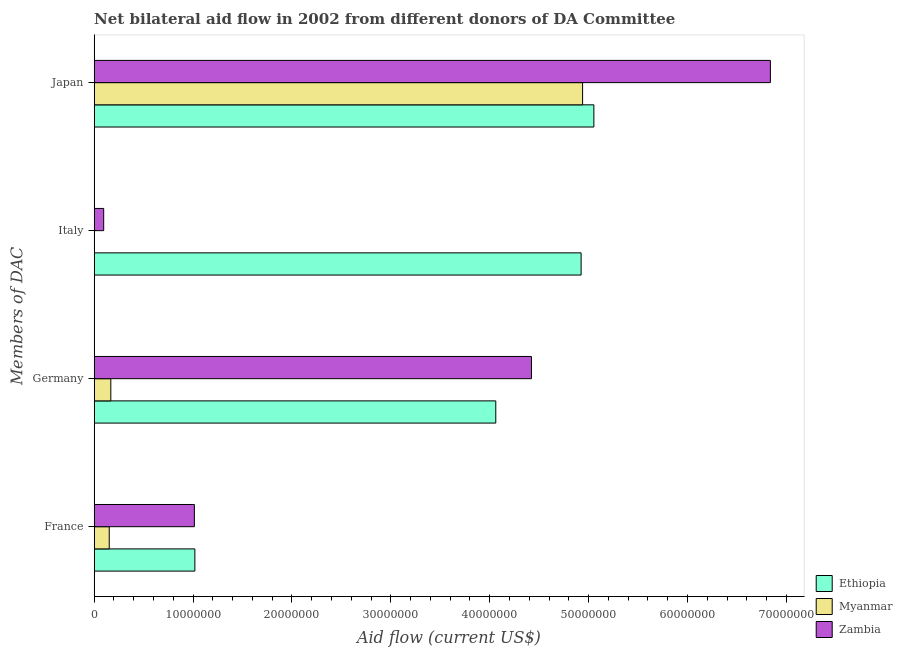How many different coloured bars are there?
Make the answer very short. 3. Are the number of bars on each tick of the Y-axis equal?
Make the answer very short. Yes. How many bars are there on the 4th tick from the bottom?
Offer a very short reply. 3. What is the amount of aid given by japan in Myanmar?
Give a very brief answer. 4.94e+07. Across all countries, what is the maximum amount of aid given by germany?
Give a very brief answer. 4.42e+07. Across all countries, what is the minimum amount of aid given by italy?
Offer a terse response. 2.00e+04. In which country was the amount of aid given by italy maximum?
Give a very brief answer. Ethiopia. In which country was the amount of aid given by germany minimum?
Offer a terse response. Myanmar. What is the total amount of aid given by france in the graph?
Offer a terse response. 2.18e+07. What is the difference between the amount of aid given by japan in Zambia and that in Myanmar?
Your response must be concise. 1.90e+07. What is the difference between the amount of aid given by italy in Zambia and the amount of aid given by france in Ethiopia?
Your answer should be compact. -9.22e+06. What is the average amount of aid given by france per country?
Provide a short and direct response. 7.28e+06. What is the difference between the amount of aid given by italy and amount of aid given by japan in Myanmar?
Make the answer very short. -4.94e+07. What is the ratio of the amount of aid given by france in Myanmar to that in Ethiopia?
Make the answer very short. 0.15. Is the difference between the amount of aid given by japan in Myanmar and Ethiopia greater than the difference between the amount of aid given by italy in Myanmar and Ethiopia?
Your response must be concise. Yes. What is the difference between the highest and the second highest amount of aid given by japan?
Make the answer very short. 1.78e+07. What is the difference between the highest and the lowest amount of aid given by france?
Your answer should be very brief. 8.66e+06. What does the 1st bar from the top in Japan represents?
Make the answer very short. Zambia. What does the 3rd bar from the bottom in Italy represents?
Offer a very short reply. Zambia. How many countries are there in the graph?
Keep it short and to the point. 3. What is the difference between two consecutive major ticks on the X-axis?
Make the answer very short. 1.00e+07. Does the graph contain any zero values?
Your answer should be compact. No. Does the graph contain grids?
Give a very brief answer. No. Where does the legend appear in the graph?
Your answer should be very brief. Bottom right. How are the legend labels stacked?
Make the answer very short. Vertical. What is the title of the graph?
Your response must be concise. Net bilateral aid flow in 2002 from different donors of DA Committee. What is the label or title of the X-axis?
Give a very brief answer. Aid flow (current US$). What is the label or title of the Y-axis?
Your answer should be very brief. Members of DAC. What is the Aid flow (current US$) of Ethiopia in France?
Give a very brief answer. 1.02e+07. What is the Aid flow (current US$) of Myanmar in France?
Keep it short and to the point. 1.52e+06. What is the Aid flow (current US$) of Zambia in France?
Give a very brief answer. 1.01e+07. What is the Aid flow (current US$) in Ethiopia in Germany?
Your answer should be compact. 4.06e+07. What is the Aid flow (current US$) of Myanmar in Germany?
Your response must be concise. 1.68e+06. What is the Aid flow (current US$) of Zambia in Germany?
Provide a succinct answer. 4.42e+07. What is the Aid flow (current US$) in Ethiopia in Italy?
Provide a succinct answer. 4.92e+07. What is the Aid flow (current US$) in Myanmar in Italy?
Ensure brevity in your answer.  2.00e+04. What is the Aid flow (current US$) of Zambia in Italy?
Provide a short and direct response. 9.60e+05. What is the Aid flow (current US$) in Ethiopia in Japan?
Make the answer very short. 5.05e+07. What is the Aid flow (current US$) of Myanmar in Japan?
Your response must be concise. 4.94e+07. What is the Aid flow (current US$) in Zambia in Japan?
Give a very brief answer. 6.84e+07. Across all Members of DAC, what is the maximum Aid flow (current US$) in Ethiopia?
Your response must be concise. 5.05e+07. Across all Members of DAC, what is the maximum Aid flow (current US$) in Myanmar?
Give a very brief answer. 4.94e+07. Across all Members of DAC, what is the maximum Aid flow (current US$) in Zambia?
Keep it short and to the point. 6.84e+07. Across all Members of DAC, what is the minimum Aid flow (current US$) of Ethiopia?
Make the answer very short. 1.02e+07. Across all Members of DAC, what is the minimum Aid flow (current US$) of Myanmar?
Your answer should be compact. 2.00e+04. Across all Members of DAC, what is the minimum Aid flow (current US$) in Zambia?
Provide a succinct answer. 9.60e+05. What is the total Aid flow (current US$) of Ethiopia in the graph?
Provide a succinct answer. 1.51e+08. What is the total Aid flow (current US$) in Myanmar in the graph?
Your answer should be very brief. 5.26e+07. What is the total Aid flow (current US$) of Zambia in the graph?
Make the answer very short. 1.24e+08. What is the difference between the Aid flow (current US$) of Ethiopia in France and that in Germany?
Your answer should be compact. -3.04e+07. What is the difference between the Aid flow (current US$) of Zambia in France and that in Germany?
Offer a terse response. -3.41e+07. What is the difference between the Aid flow (current US$) of Ethiopia in France and that in Italy?
Your answer should be compact. -3.91e+07. What is the difference between the Aid flow (current US$) in Myanmar in France and that in Italy?
Keep it short and to the point. 1.50e+06. What is the difference between the Aid flow (current US$) in Zambia in France and that in Italy?
Ensure brevity in your answer.  9.17e+06. What is the difference between the Aid flow (current US$) of Ethiopia in France and that in Japan?
Provide a succinct answer. -4.04e+07. What is the difference between the Aid flow (current US$) of Myanmar in France and that in Japan?
Your response must be concise. -4.79e+07. What is the difference between the Aid flow (current US$) of Zambia in France and that in Japan?
Your answer should be compact. -5.82e+07. What is the difference between the Aid flow (current US$) in Ethiopia in Germany and that in Italy?
Offer a very short reply. -8.63e+06. What is the difference between the Aid flow (current US$) in Myanmar in Germany and that in Italy?
Offer a very short reply. 1.66e+06. What is the difference between the Aid flow (current US$) of Zambia in Germany and that in Italy?
Offer a terse response. 4.33e+07. What is the difference between the Aid flow (current US$) in Ethiopia in Germany and that in Japan?
Offer a very short reply. -9.92e+06. What is the difference between the Aid flow (current US$) of Myanmar in Germany and that in Japan?
Give a very brief answer. -4.77e+07. What is the difference between the Aid flow (current US$) of Zambia in Germany and that in Japan?
Provide a succinct answer. -2.42e+07. What is the difference between the Aid flow (current US$) of Ethiopia in Italy and that in Japan?
Offer a terse response. -1.29e+06. What is the difference between the Aid flow (current US$) in Myanmar in Italy and that in Japan?
Provide a succinct answer. -4.94e+07. What is the difference between the Aid flow (current US$) of Zambia in Italy and that in Japan?
Give a very brief answer. -6.74e+07. What is the difference between the Aid flow (current US$) in Ethiopia in France and the Aid flow (current US$) in Myanmar in Germany?
Your answer should be very brief. 8.50e+06. What is the difference between the Aid flow (current US$) of Ethiopia in France and the Aid flow (current US$) of Zambia in Germany?
Offer a terse response. -3.40e+07. What is the difference between the Aid flow (current US$) of Myanmar in France and the Aid flow (current US$) of Zambia in Germany?
Keep it short and to the point. -4.27e+07. What is the difference between the Aid flow (current US$) in Ethiopia in France and the Aid flow (current US$) in Myanmar in Italy?
Provide a short and direct response. 1.02e+07. What is the difference between the Aid flow (current US$) of Ethiopia in France and the Aid flow (current US$) of Zambia in Italy?
Keep it short and to the point. 9.22e+06. What is the difference between the Aid flow (current US$) in Myanmar in France and the Aid flow (current US$) in Zambia in Italy?
Your response must be concise. 5.60e+05. What is the difference between the Aid flow (current US$) of Ethiopia in France and the Aid flow (current US$) of Myanmar in Japan?
Provide a succinct answer. -3.92e+07. What is the difference between the Aid flow (current US$) of Ethiopia in France and the Aid flow (current US$) of Zambia in Japan?
Make the answer very short. -5.82e+07. What is the difference between the Aid flow (current US$) in Myanmar in France and the Aid flow (current US$) in Zambia in Japan?
Ensure brevity in your answer.  -6.69e+07. What is the difference between the Aid flow (current US$) in Ethiopia in Germany and the Aid flow (current US$) in Myanmar in Italy?
Give a very brief answer. 4.06e+07. What is the difference between the Aid flow (current US$) of Ethiopia in Germany and the Aid flow (current US$) of Zambia in Italy?
Your answer should be compact. 3.96e+07. What is the difference between the Aid flow (current US$) of Myanmar in Germany and the Aid flow (current US$) of Zambia in Italy?
Provide a short and direct response. 7.20e+05. What is the difference between the Aid flow (current US$) of Ethiopia in Germany and the Aid flow (current US$) of Myanmar in Japan?
Give a very brief answer. -8.78e+06. What is the difference between the Aid flow (current US$) of Ethiopia in Germany and the Aid flow (current US$) of Zambia in Japan?
Your answer should be very brief. -2.78e+07. What is the difference between the Aid flow (current US$) of Myanmar in Germany and the Aid flow (current US$) of Zambia in Japan?
Your answer should be very brief. -6.67e+07. What is the difference between the Aid flow (current US$) in Ethiopia in Italy and the Aid flow (current US$) in Zambia in Japan?
Make the answer very short. -1.91e+07. What is the difference between the Aid flow (current US$) of Myanmar in Italy and the Aid flow (current US$) of Zambia in Japan?
Offer a very short reply. -6.84e+07. What is the average Aid flow (current US$) in Ethiopia per Members of DAC?
Your answer should be very brief. 3.76e+07. What is the average Aid flow (current US$) in Myanmar per Members of DAC?
Keep it short and to the point. 1.32e+07. What is the average Aid flow (current US$) in Zambia per Members of DAC?
Provide a succinct answer. 3.09e+07. What is the difference between the Aid flow (current US$) in Ethiopia and Aid flow (current US$) in Myanmar in France?
Offer a terse response. 8.66e+06. What is the difference between the Aid flow (current US$) of Ethiopia and Aid flow (current US$) of Zambia in France?
Give a very brief answer. 5.00e+04. What is the difference between the Aid flow (current US$) of Myanmar and Aid flow (current US$) of Zambia in France?
Offer a very short reply. -8.61e+06. What is the difference between the Aid flow (current US$) of Ethiopia and Aid flow (current US$) of Myanmar in Germany?
Your answer should be very brief. 3.89e+07. What is the difference between the Aid flow (current US$) of Ethiopia and Aid flow (current US$) of Zambia in Germany?
Your answer should be compact. -3.61e+06. What is the difference between the Aid flow (current US$) of Myanmar and Aid flow (current US$) of Zambia in Germany?
Offer a very short reply. -4.25e+07. What is the difference between the Aid flow (current US$) of Ethiopia and Aid flow (current US$) of Myanmar in Italy?
Offer a terse response. 4.92e+07. What is the difference between the Aid flow (current US$) of Ethiopia and Aid flow (current US$) of Zambia in Italy?
Provide a short and direct response. 4.83e+07. What is the difference between the Aid flow (current US$) of Myanmar and Aid flow (current US$) of Zambia in Italy?
Your answer should be very brief. -9.40e+05. What is the difference between the Aid flow (current US$) in Ethiopia and Aid flow (current US$) in Myanmar in Japan?
Your answer should be compact. 1.14e+06. What is the difference between the Aid flow (current US$) of Ethiopia and Aid flow (current US$) of Zambia in Japan?
Give a very brief answer. -1.78e+07. What is the difference between the Aid flow (current US$) of Myanmar and Aid flow (current US$) of Zambia in Japan?
Make the answer very short. -1.90e+07. What is the ratio of the Aid flow (current US$) in Ethiopia in France to that in Germany?
Provide a succinct answer. 0.25. What is the ratio of the Aid flow (current US$) of Myanmar in France to that in Germany?
Your response must be concise. 0.9. What is the ratio of the Aid flow (current US$) of Zambia in France to that in Germany?
Offer a very short reply. 0.23. What is the ratio of the Aid flow (current US$) in Ethiopia in France to that in Italy?
Keep it short and to the point. 0.21. What is the ratio of the Aid flow (current US$) of Myanmar in France to that in Italy?
Provide a short and direct response. 76. What is the ratio of the Aid flow (current US$) of Zambia in France to that in Italy?
Keep it short and to the point. 10.55. What is the ratio of the Aid flow (current US$) of Ethiopia in France to that in Japan?
Give a very brief answer. 0.2. What is the ratio of the Aid flow (current US$) of Myanmar in France to that in Japan?
Your answer should be very brief. 0.03. What is the ratio of the Aid flow (current US$) of Zambia in France to that in Japan?
Your answer should be compact. 0.15. What is the ratio of the Aid flow (current US$) in Ethiopia in Germany to that in Italy?
Your response must be concise. 0.82. What is the ratio of the Aid flow (current US$) in Myanmar in Germany to that in Italy?
Provide a succinct answer. 84. What is the ratio of the Aid flow (current US$) in Zambia in Germany to that in Italy?
Ensure brevity in your answer.  46.06. What is the ratio of the Aid flow (current US$) in Ethiopia in Germany to that in Japan?
Keep it short and to the point. 0.8. What is the ratio of the Aid flow (current US$) in Myanmar in Germany to that in Japan?
Ensure brevity in your answer.  0.03. What is the ratio of the Aid flow (current US$) of Zambia in Germany to that in Japan?
Provide a succinct answer. 0.65. What is the ratio of the Aid flow (current US$) of Ethiopia in Italy to that in Japan?
Make the answer very short. 0.97. What is the ratio of the Aid flow (current US$) of Zambia in Italy to that in Japan?
Offer a terse response. 0.01. What is the difference between the highest and the second highest Aid flow (current US$) of Ethiopia?
Keep it short and to the point. 1.29e+06. What is the difference between the highest and the second highest Aid flow (current US$) in Myanmar?
Offer a very short reply. 4.77e+07. What is the difference between the highest and the second highest Aid flow (current US$) in Zambia?
Ensure brevity in your answer.  2.42e+07. What is the difference between the highest and the lowest Aid flow (current US$) of Ethiopia?
Ensure brevity in your answer.  4.04e+07. What is the difference between the highest and the lowest Aid flow (current US$) of Myanmar?
Offer a terse response. 4.94e+07. What is the difference between the highest and the lowest Aid flow (current US$) in Zambia?
Make the answer very short. 6.74e+07. 